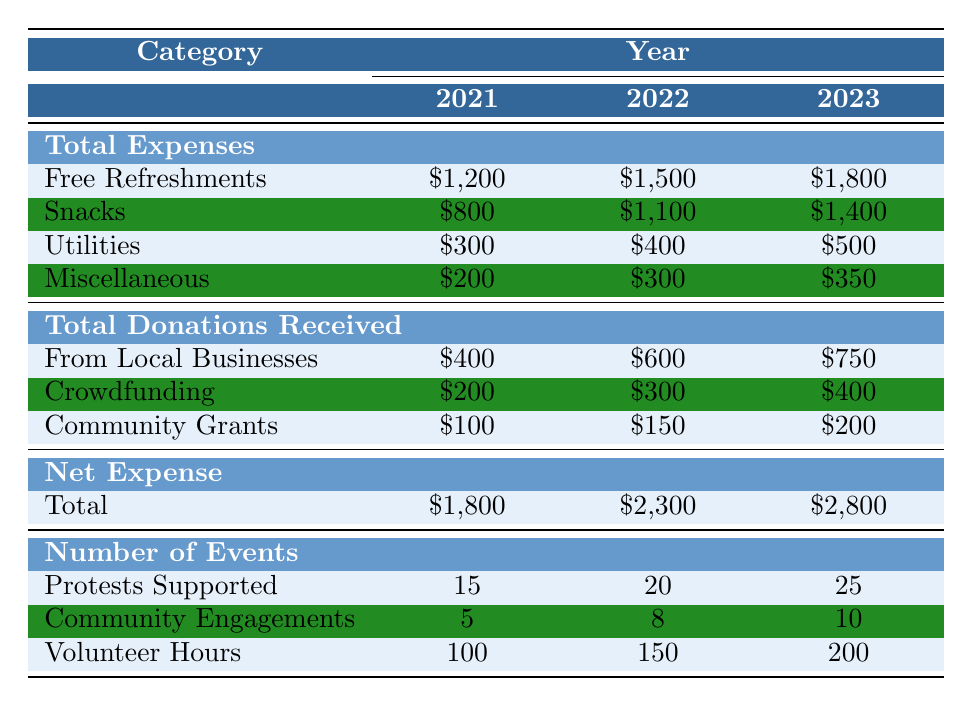What was the total expense for free refreshments in 2022? The table shows that the total expense for free refreshments in 2022 is $1,500.
Answer: $1,500 How much did the café spend on snacks in 2023? The table indicates that the café spent $1,400 on snacks in 2023.
Answer: $1,400 What is the total amount received from local businesses in 2021? According to the table, the total amount received from local businesses in 2021 is $400.
Answer: $400 What is the net expense for the year 2021? The net expense for 2021 is calculated as total expenses ($1,800) minus total donations received (total of $700), resulting in $1,800.
Answer: $1,800 In which year did the snack expenses see the highest increase compared to the previous year? By examining the snack expenses, we see that from 2022 to 2023, the increase is $300 (from $1,100 to $1,400), which is larger than previous increases.
Answer: Between 2022 and 2023 How much did the café receive from crowdfunding in total from 2021 to 2023? The crowdfunding amounts are $200 in 2021, $300 in 2022, and $400 in 2023; summing them gives $200 + $300 + $400 = $900.
Answer: $900 Did the café support more protests in 2023 compared to 2021? The table shows that 25 protests were supported in 2023 compared to 15 in 2021, indicating a yes answer to this question.
Answer: Yes What is the average number of volunteer hours over the three years? The total volunteer hours are 100 + 150 + 200 = 450, and dividing this by 3 gives an average of 150 hours per year.
Answer: 150 What was the change in total donations received from local businesses from 2021 to 2023? The total donations from local businesses increased from $400 in 2021 to $750 in 2023, resulting in a change of $750 - $400 = $350.
Answer: $350 How much more did the café spend on utilities in 2023 compared to 2021? The expense for utilities in 2023 is $500, while in 2021 it was $300; the difference is $500 - $300 = $200.
Answer: $200 If the total expenses were to be increased by 10% in 2024, what would be the expected expenses for free refreshments? The current expense for free refreshments in 2023 is $1,800. A 10% increase means $1,800 * 0.10 = $180, leading to expected expenses of $1,800 + $180 = $1,980.
Answer: $1,980 